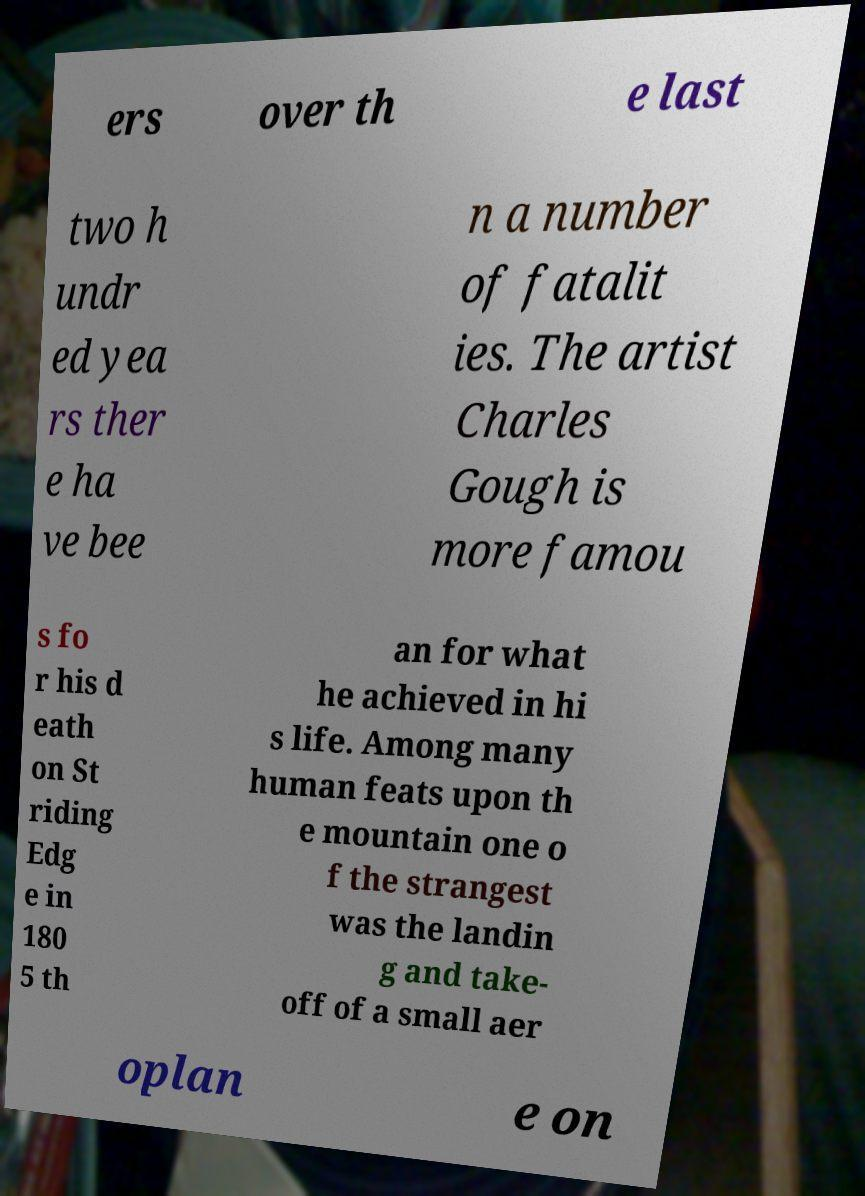What messages or text are displayed in this image? I need them in a readable, typed format. ers over th e last two h undr ed yea rs ther e ha ve bee n a number of fatalit ies. The artist Charles Gough is more famou s fo r his d eath on St riding Edg e in 180 5 th an for what he achieved in hi s life. Among many human feats upon th e mountain one o f the strangest was the landin g and take- off of a small aer oplan e on 